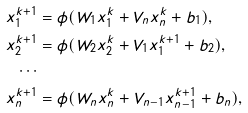<formula> <loc_0><loc_0><loc_500><loc_500>x _ { 1 } ^ { k + 1 } & = \phi ( W _ { 1 } x _ { 1 } ^ { k } + V _ { n } x _ { n } ^ { k } + b _ { 1 } ) , \\ x _ { 2 } ^ { k + 1 } & = \phi ( W _ { 2 } x _ { 2 } ^ { k } + V _ { 1 } x _ { 1 } ^ { k + 1 } + b _ { 2 } ) , \\ \cdots \\ x _ { n } ^ { k + 1 } & = \phi ( W _ { n } x _ { n } ^ { k } + V _ { n - 1 } x _ { n - 1 } ^ { k + 1 } + b _ { n } ) ,</formula> 